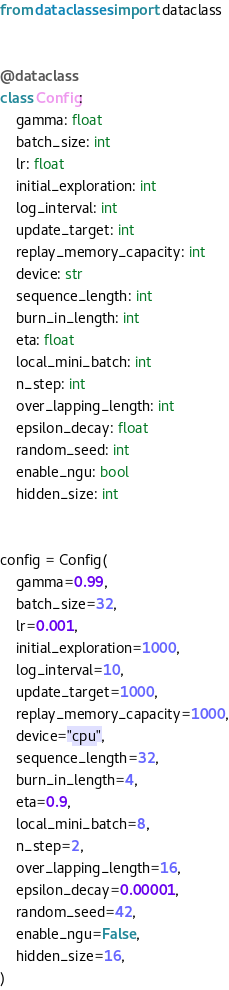<code> <loc_0><loc_0><loc_500><loc_500><_Python_>from dataclasses import dataclass


@dataclass
class Config:
    gamma: float
    batch_size: int
    lr: float
    initial_exploration: int
    log_interval: int
    update_target: int
    replay_memory_capacity: int
    device: str
    sequence_length: int
    burn_in_length: int
    eta: float
    local_mini_batch: int
    n_step: int
    over_lapping_length: int
    epsilon_decay: float
    random_seed: int
    enable_ngu: bool
    hidden_size: int


config = Config(
    gamma=0.99,
    batch_size=32,
    lr=0.001,
    initial_exploration=1000,
    log_interval=10,
    update_target=1000,
    replay_memory_capacity=1000,
    device="cpu",
    sequence_length=32,
    burn_in_length=4,
    eta=0.9,
    local_mini_batch=8,
    n_step=2,
    over_lapping_length=16,
    epsilon_decay=0.00001,
    random_seed=42,
    enable_ngu=False,
    hidden_size=16,
)
</code> 